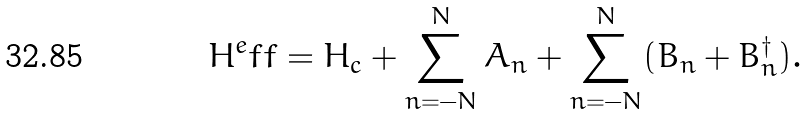Convert formula to latex. <formula><loc_0><loc_0><loc_500><loc_500>H ^ { e } f f = H _ { c } + \sum _ { n = - N } ^ { N } A _ { n } + \sum _ { n = - N } ^ { N } ( B _ { n } + B ^ { \dag } _ { n } ) .</formula> 